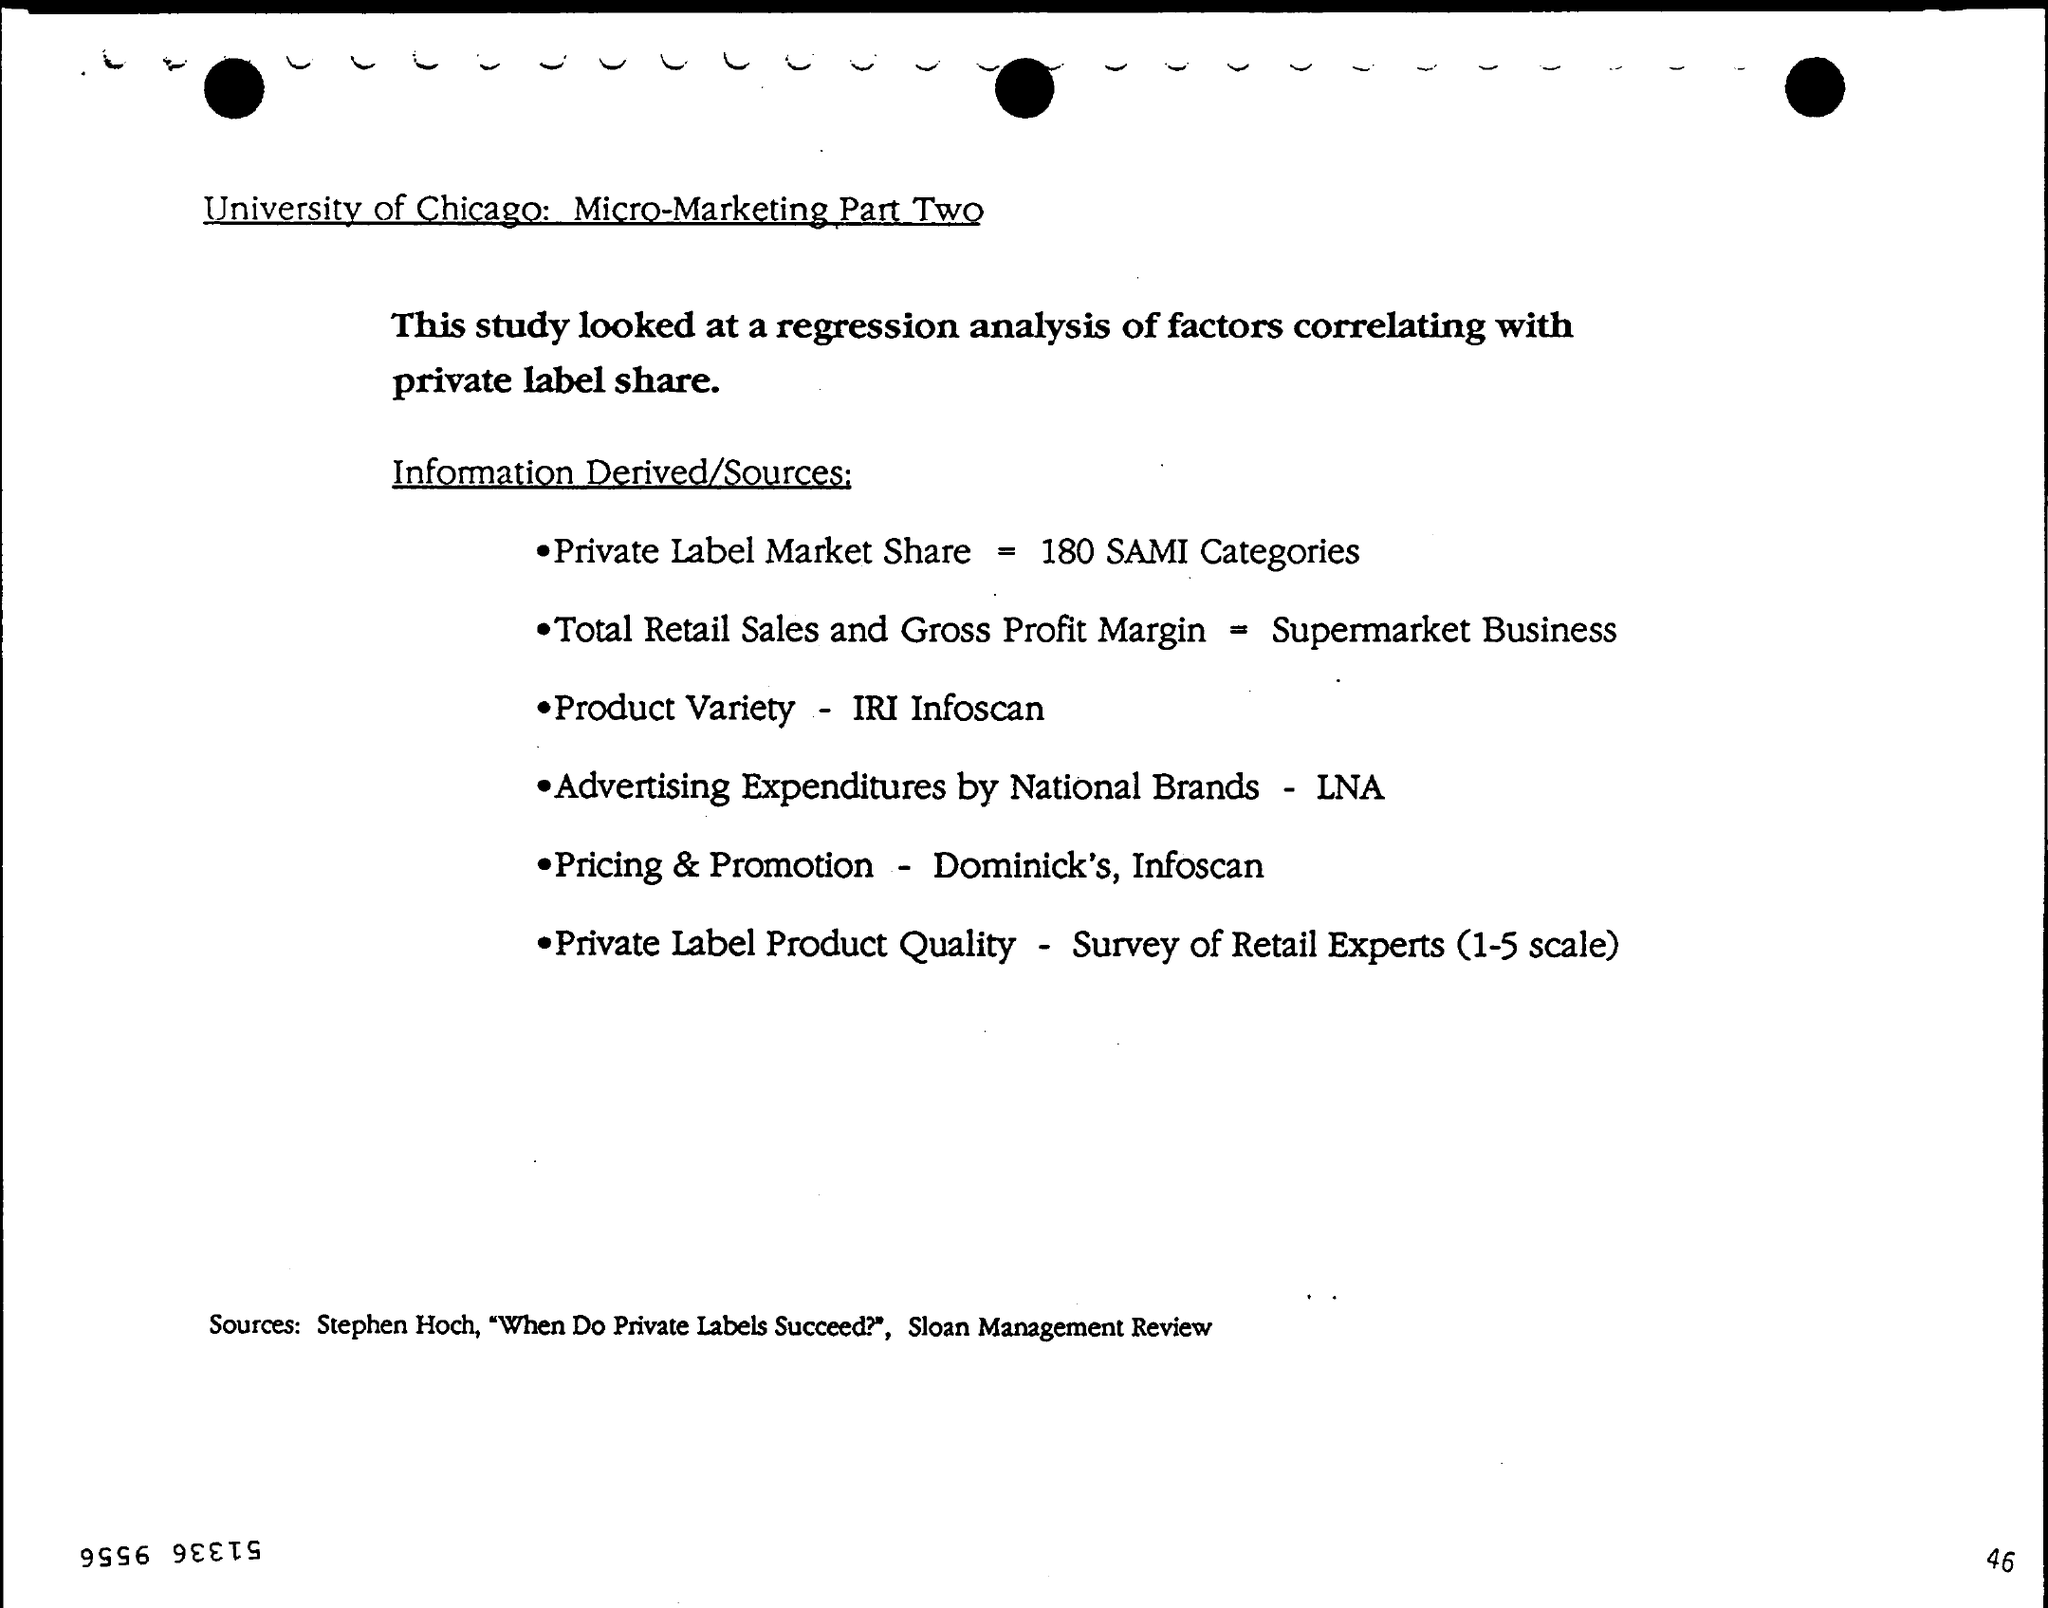List a handful of essential elements in this visual. What is the advertising expenditures by national brands?" is a question that is seeking information about the amount of money that national companies are spending on advertising. The total retail sales and gross profit margin for a supermarket business is the total amount of revenue generated from the sale of goods to customers, minus the cost of those goods, expressed as a percentage of sales. This metric provides insight into the profitability of the business and the efficiency of its pricing strategy. The Pricing & Promotion research includes a study of Dominick's and Infoscan to gather information on pricing and promotion strategies in the grocery industry. The private label market share is the percentage of sales generated by retailers' own brands, covering 180 categories of products, according to the Sales and Market Institute (SAMI). The Product Variety is a measure of the different types of products available in a given market, as determined by IRI Infoscan. 